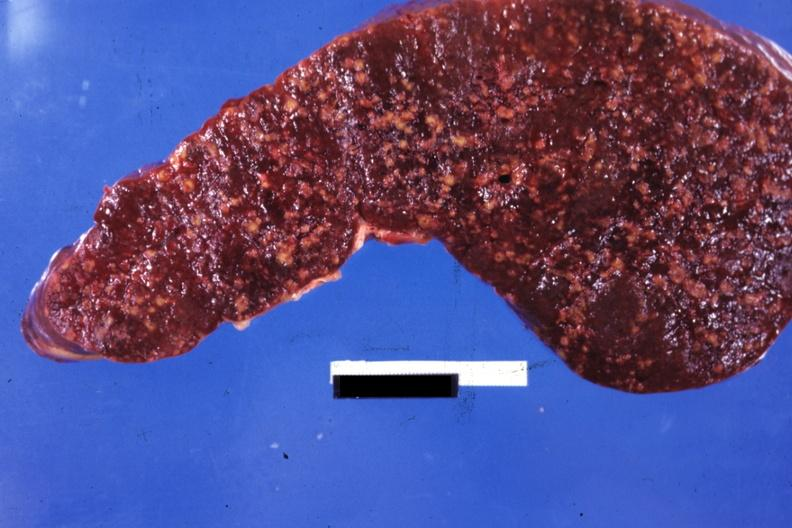what is present?
Answer the question using a single word or phrase. Malignant histiocytosis 